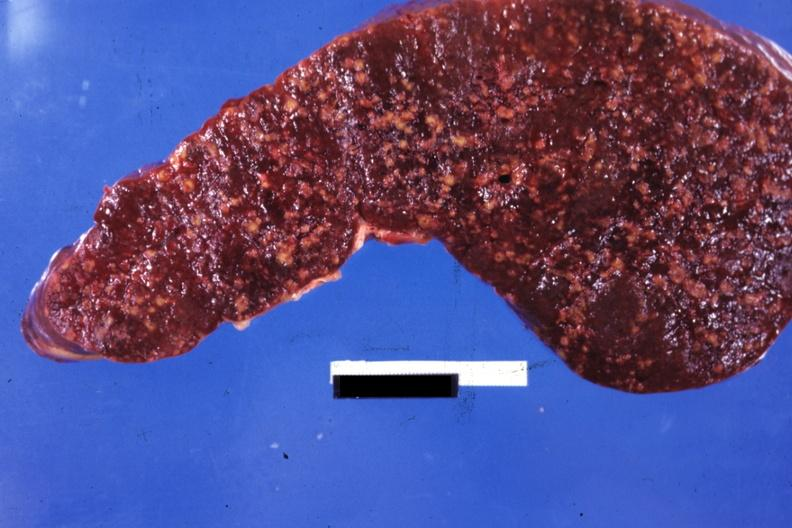what is present?
Answer the question using a single word or phrase. Malignant histiocytosis 